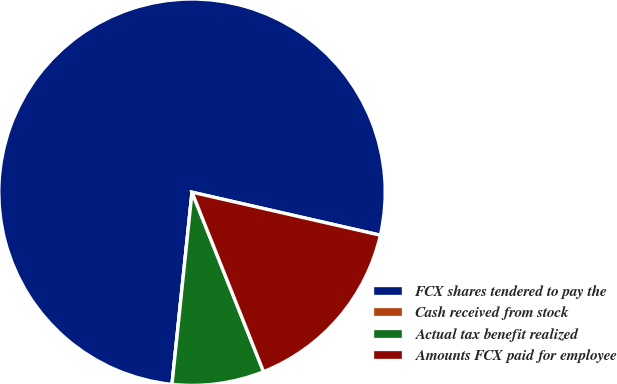Convert chart to OTSL. <chart><loc_0><loc_0><loc_500><loc_500><pie_chart><fcel>FCX shares tendered to pay the<fcel>Cash received from stock<fcel>Actual tax benefit realized<fcel>Amounts FCX paid for employee<nl><fcel>76.92%<fcel>0.0%<fcel>7.69%<fcel>15.39%<nl></chart> 